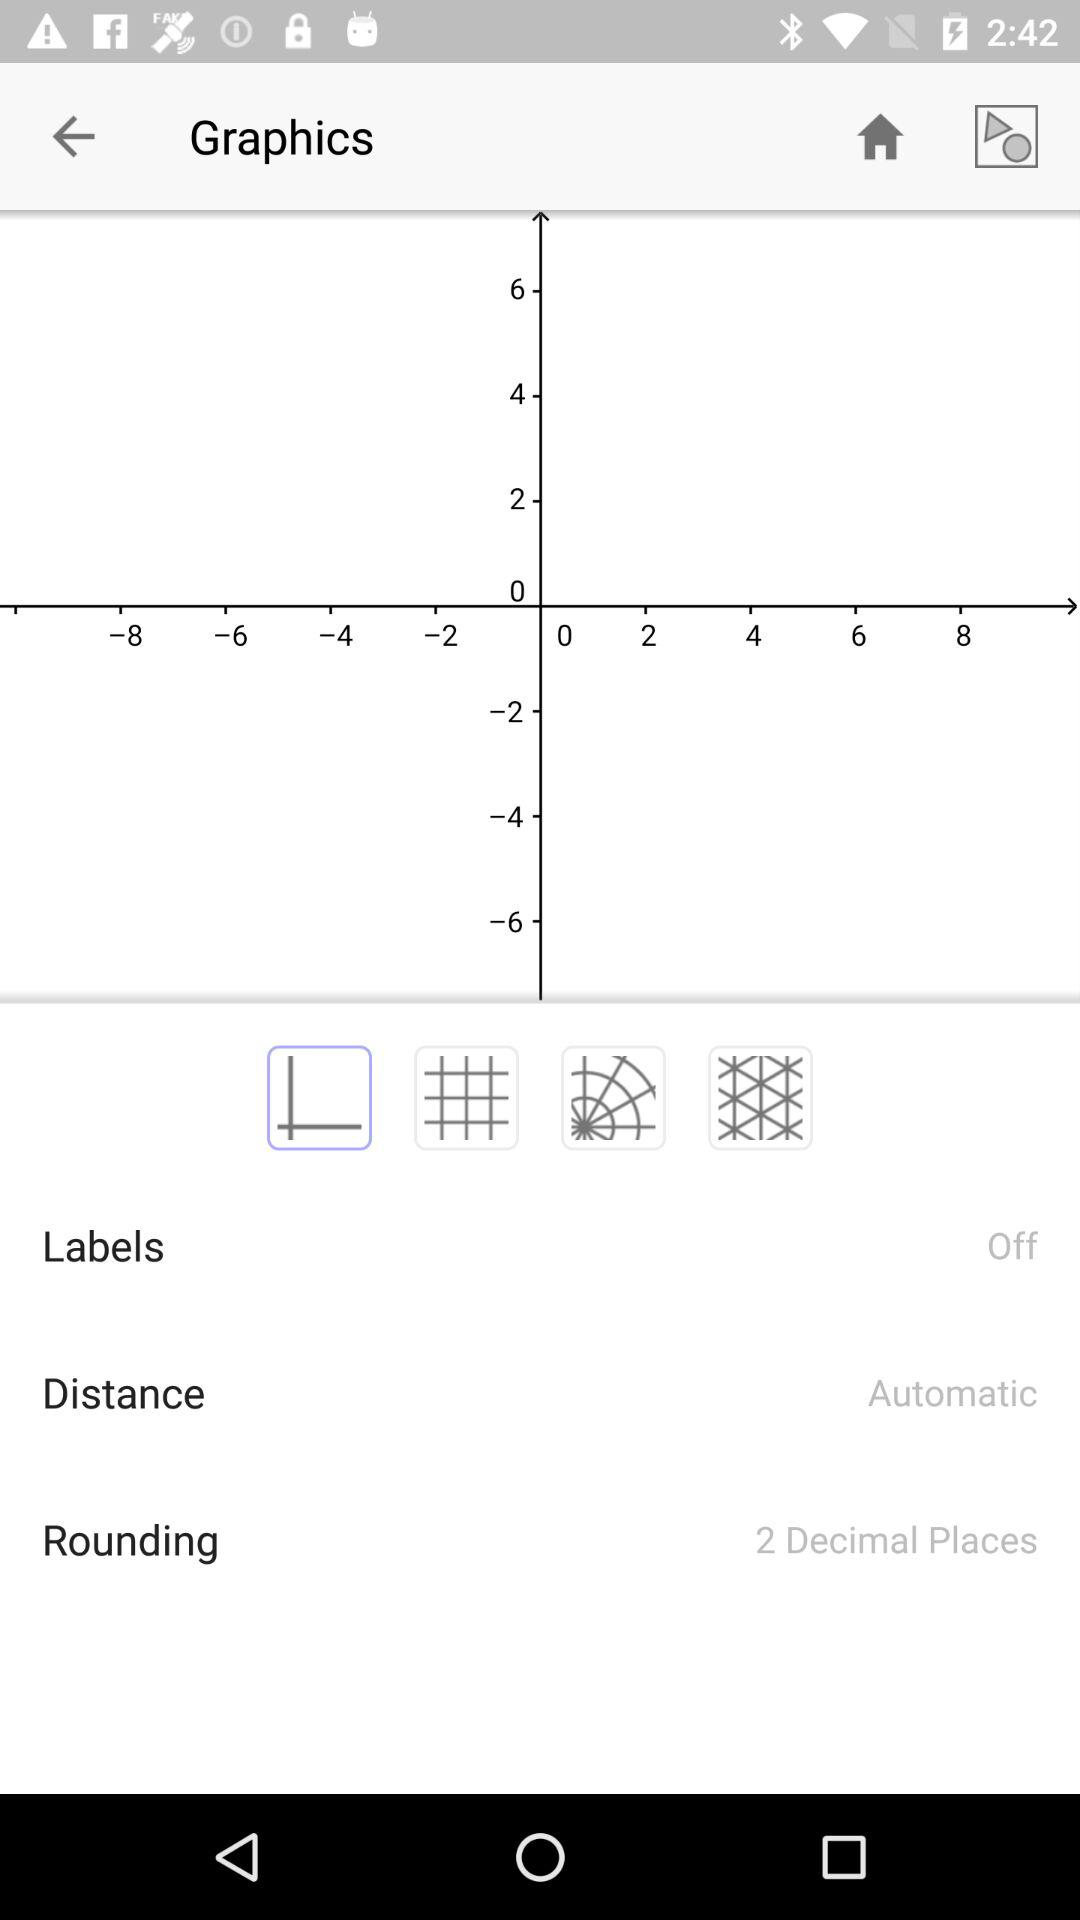How is the distance calculated? The distance is calculated "Automatic". 